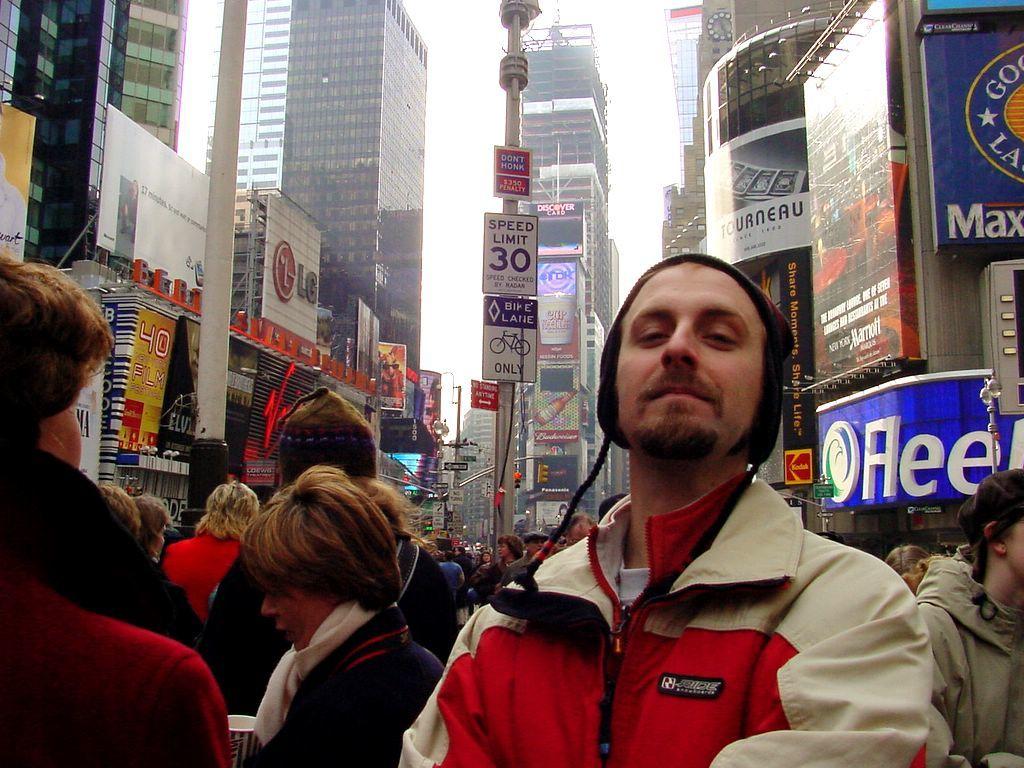What is the speed limit?
Provide a succinct answer. 30. 